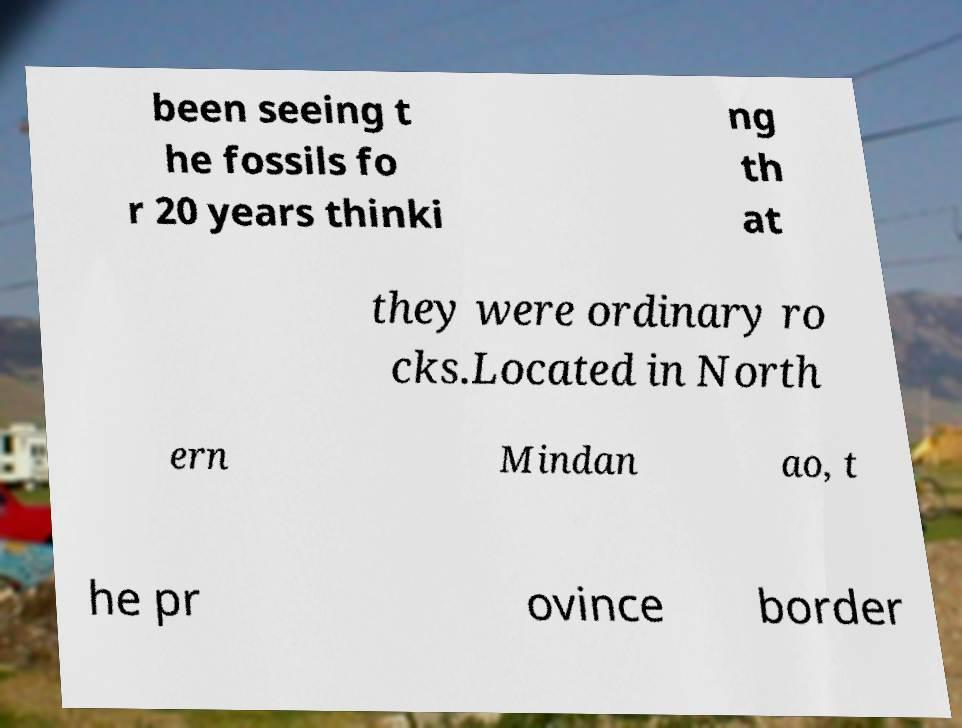There's text embedded in this image that I need extracted. Can you transcribe it verbatim? been seeing t he fossils fo r 20 years thinki ng th at they were ordinary ro cks.Located in North ern Mindan ao, t he pr ovince border 